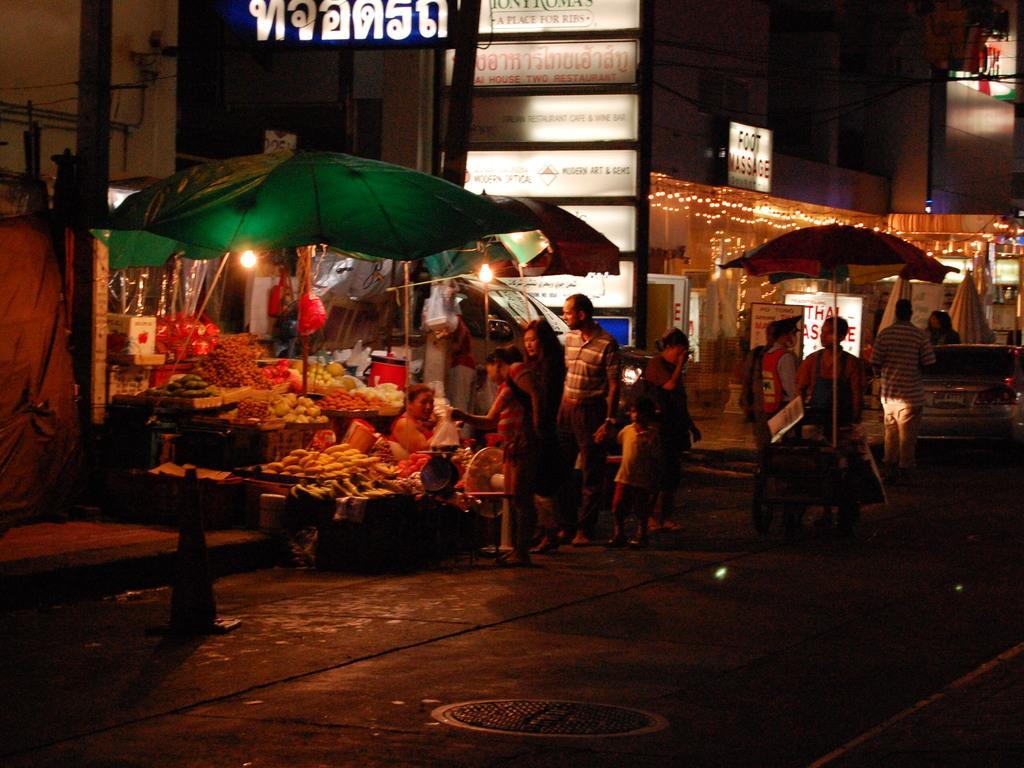How would you summarize this image in a sentence or two? As we can see in the image there are buildings, banners, lights, umbrellas, group of people and vegetables. The image is little dark. 